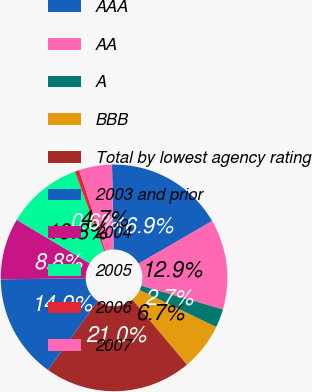Convert chart to OTSL. <chart><loc_0><loc_0><loc_500><loc_500><pie_chart><fcel>AAA<fcel>AA<fcel>A<fcel>BBB<fcel>Total by lowest agency rating<fcel>2003 and prior<fcel>2004<fcel>2005<fcel>2006<fcel>2007<nl><fcel>16.93%<fcel>12.85%<fcel>2.66%<fcel>6.74%<fcel>21.01%<fcel>14.89%<fcel>8.78%<fcel>10.82%<fcel>0.62%<fcel>4.7%<nl></chart> 